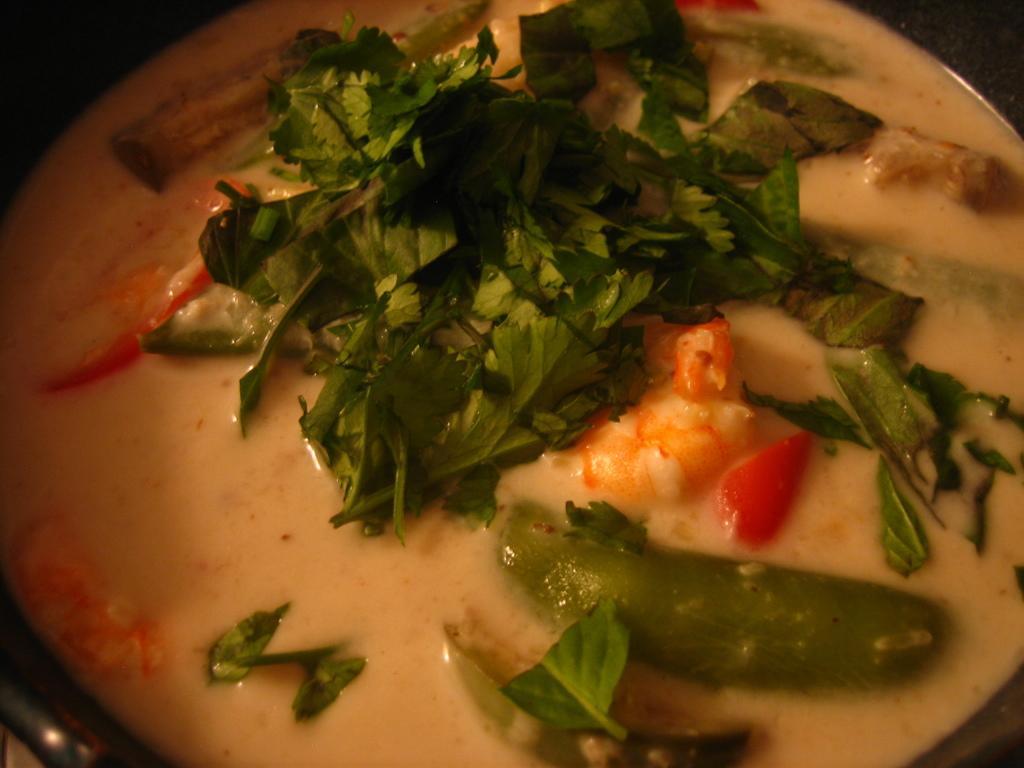Can you describe this image briefly? In this image, we can see some food in a container. 